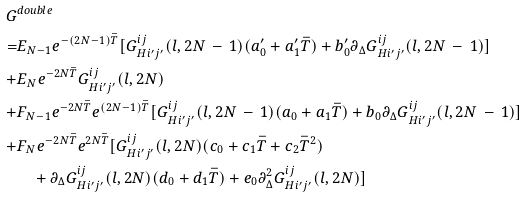<formula> <loc_0><loc_0><loc_500><loc_500>G & ^ { d o u b l e } \\ = & E _ { N - 1 } e ^ { - ( 2 N - 1 ) \bar { T } } [ G ^ { i j } _ { H i ^ { \prime } j ^ { \prime } } ( l , 2 N \, - \, 1 ) ( a ^ { \prime } _ { 0 } + a ^ { \prime } _ { 1 } \bar { T } ) + b ^ { \prime } _ { 0 } \partial _ { \Delta } G ^ { i j } _ { H i ^ { \prime } j ^ { \prime } } ( l , 2 N \, - \, 1 ) ] \\ + & E _ { N } e ^ { - 2 N \bar { T } } G ^ { i j } _ { H i ^ { \prime } j ^ { \prime } } ( l , 2 N ) \\ + & F _ { N - 1 } e ^ { - 2 N \bar { T } } e ^ { ( 2 N - 1 ) \bar { T } } [ G ^ { i j } _ { H i ^ { \prime } j ^ { \prime } } ( l , 2 N \, - \, 1 ) ( a _ { 0 } + a _ { 1 } \bar { T } ) + b _ { 0 } \partial _ { \Delta } G ^ { i j } _ { H i ^ { \prime } j ^ { \prime } } ( l , 2 N \, - \, 1 ) ] \\ + & F _ { N } e ^ { - 2 N \bar { T } } e ^ { 2 N \bar { T } } [ G ^ { i j } _ { H i ^ { \prime } j ^ { \prime } } ( l , 2 N ) ( c _ { 0 } + c _ { 1 } \bar { T } + c _ { 2 } \bar { T } ^ { 2 } ) \\ & \quad + \partial _ { \Delta } G ^ { i j } _ { H i ^ { \prime } j ^ { \prime } } ( l , 2 N ) ( d _ { 0 } + d _ { 1 } \bar { T } ) + e _ { 0 } \partial ^ { 2 } _ { \Delta } G ^ { i j } _ { H i ^ { \prime } j ^ { \prime } } ( l , 2 N ) ]</formula> 